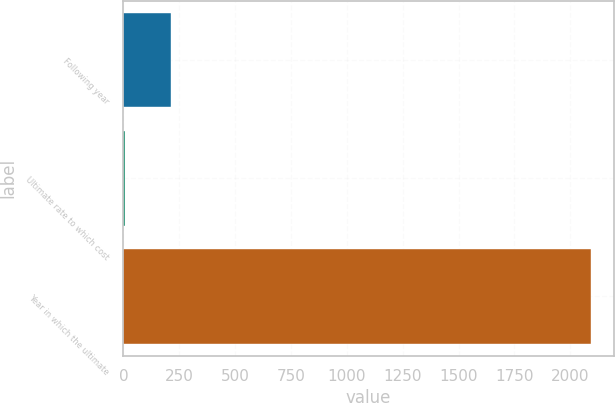Convert chart to OTSL. <chart><loc_0><loc_0><loc_500><loc_500><bar_chart><fcel>Following year<fcel>Ultimate rate to which cost<fcel>Year in which the ultimate<nl><fcel>213.24<fcel>4.6<fcel>2091<nl></chart> 